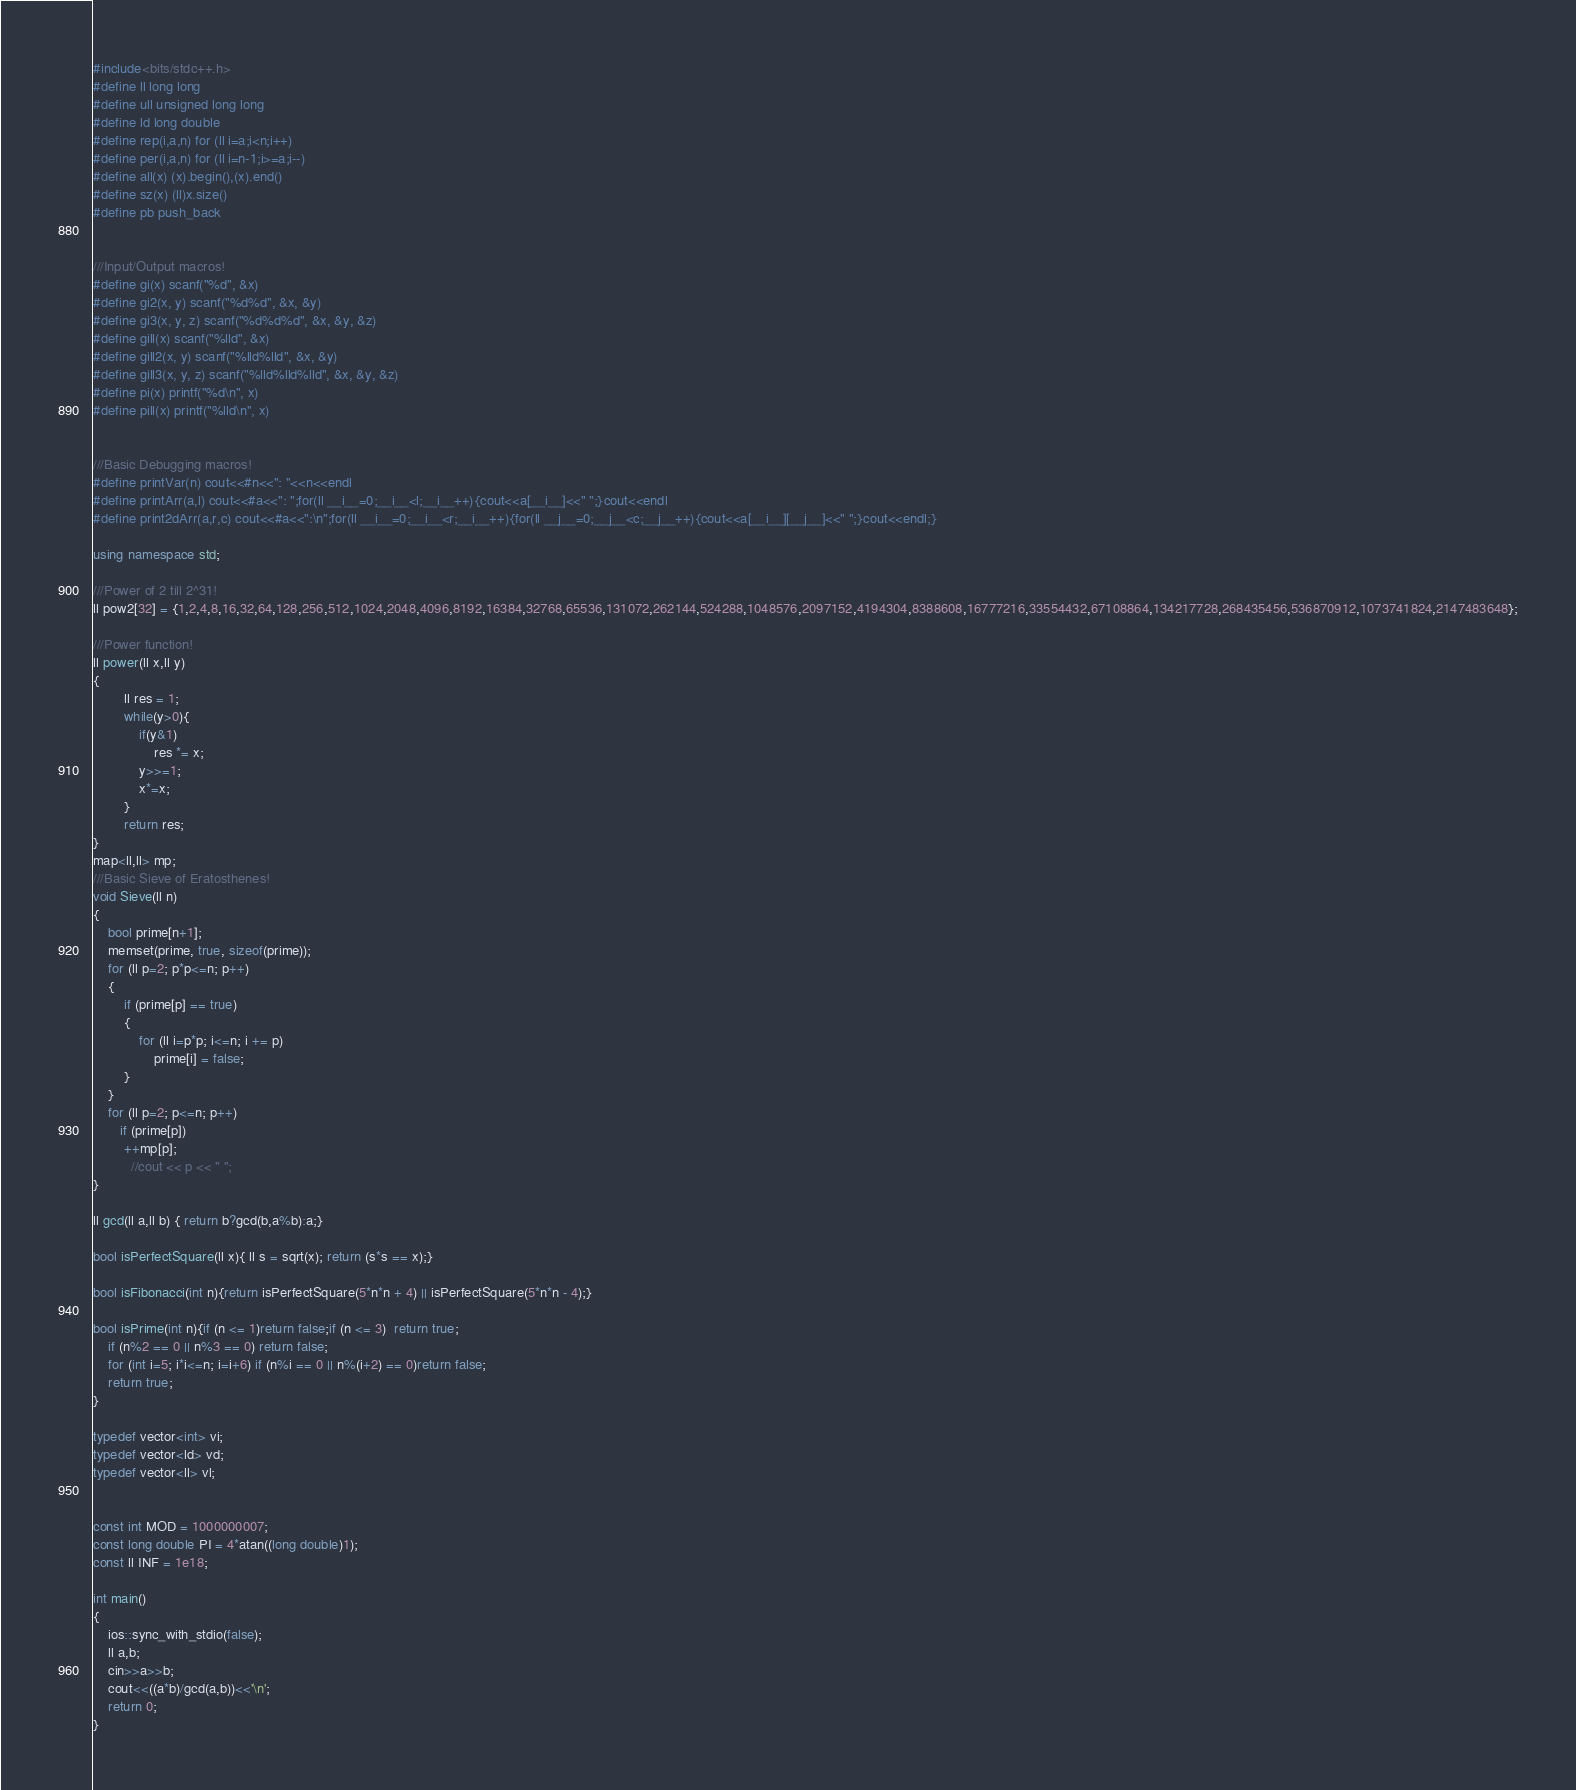<code> <loc_0><loc_0><loc_500><loc_500><_C++_>#include<bits/stdc++.h>
#define ll long long
#define ull unsigned long long
#define ld long double
#define rep(i,a,n) for (ll i=a;i<n;i++)
#define per(i,a,n) for (ll i=n-1;i>=a;i--)
#define all(x) (x).begin(),(x).end()
#define sz(x) (ll)x.size()
#define pb push_back


///Input/Output macros!
#define gi(x) scanf("%d", &x)
#define gi2(x, y) scanf("%d%d", &x, &y)
#define gi3(x, y, z) scanf("%d%d%d", &x, &y, &z)
#define gill(x) scanf("%lld", &x)
#define gill2(x, y) scanf("%lld%lld", &x, &y)
#define gill3(x, y, z) scanf("%lld%lld%lld", &x, &y, &z)
#define pi(x) printf("%d\n", x)
#define pill(x) printf("%lld\n", x)


///Basic Debugging macros!
#define printVar(n) cout<<#n<<": "<<n<<endl
#define printArr(a,l) cout<<#a<<": ";for(ll __i__=0;__i__<l;__i__++){cout<<a[__i__]<<" ";}cout<<endl
#define print2dArr(a,r,c) cout<<#a<<":\n";for(ll __i__=0;__i__<r;__i__++){for(ll __j__=0;__j__<c;__j__++){cout<<a[__i__][__j__]<<" ";}cout<<endl;}

using namespace std;

///Power of 2 till 2^31!
ll pow2[32] = {1,2,4,8,16,32,64,128,256,512,1024,2048,4096,8192,16384,32768,65536,131072,262144,524288,1048576,2097152,4194304,8388608,16777216,33554432,67108864,134217728,268435456,536870912,1073741824,2147483648};

///Power function!
ll power(ll x,ll y)
{
        ll res = 1;
        while(y>0){
            if(y&1)
                res *= x;
            y>>=1;
            x*=x;
        }
        return res;
}
map<ll,ll> mp;
///Basic Sieve of Eratosthenes!
void Sieve(ll n)
{
    bool prime[n+1];
    memset(prime, true, sizeof(prime));
    for (ll p=2; p*p<=n; p++)
    {
        if (prime[p] == true)
        {
            for (ll i=p*p; i<=n; i += p)
                prime[i] = false;
        }
    }
    for (ll p=2; p<=n; p++)
       if (prime[p])
        ++mp[p];
          //cout << p << " ";
}

ll gcd(ll a,ll b) { return b?gcd(b,a%b):a;}

bool isPerfectSquare(ll x){ ll s = sqrt(x); return (s*s == x);}

bool isFibonacci(int n){return isPerfectSquare(5*n*n + 4) || isPerfectSquare(5*n*n - 4);}

bool isPrime(int n){if (n <= 1)return false;if (n <= 3)  return true;
    if (n%2 == 0 || n%3 == 0) return false;
    for (int i=5; i*i<=n; i=i+6) if (n%i == 0 || n%(i+2) == 0)return false;
    return true;
}

typedef vector<int> vi;
typedef vector<ld> vd;
typedef vector<ll> vl;


const int MOD = 1000000007;
const long double PI = 4*atan((long double)1);
const ll INF = 1e18;

int main()
{
    ios::sync_with_stdio(false);
    ll a,b;
    cin>>a>>b;
    cout<<((a*b)/gcd(a,b))<<'\n';
    return 0;
}
</code> 